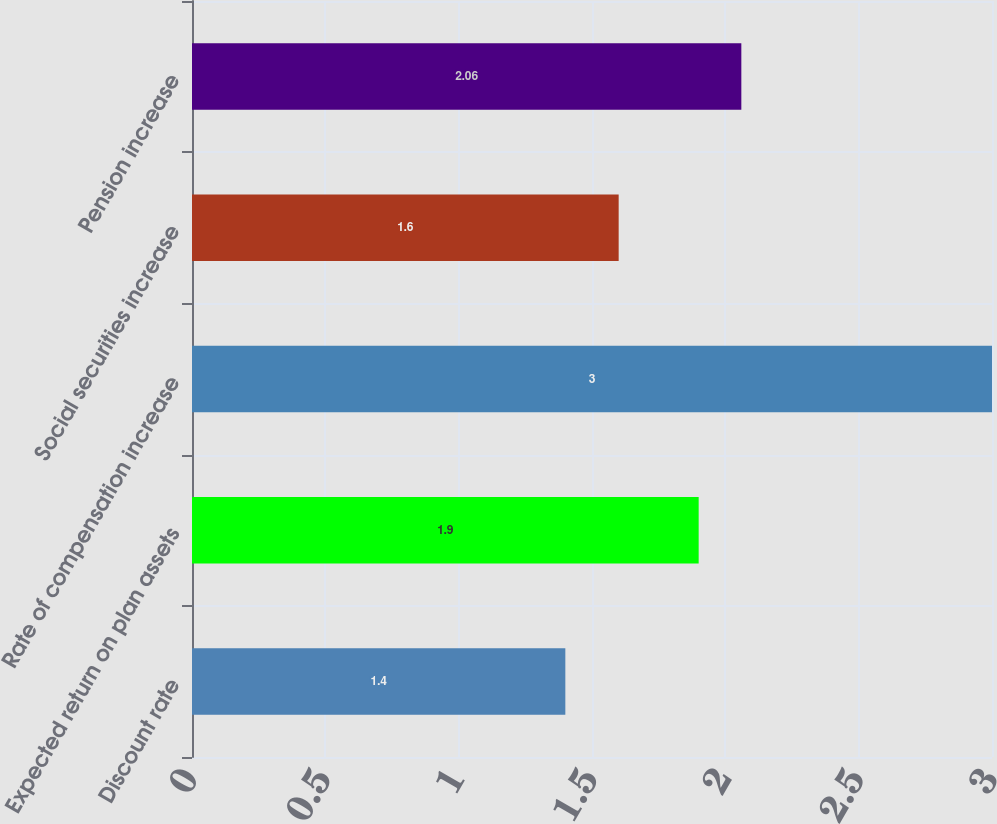Convert chart to OTSL. <chart><loc_0><loc_0><loc_500><loc_500><bar_chart><fcel>Discount rate<fcel>Expected return on plan assets<fcel>Rate of compensation increase<fcel>Social securities increase<fcel>Pension increase<nl><fcel>1.4<fcel>1.9<fcel>3<fcel>1.6<fcel>2.06<nl></chart> 